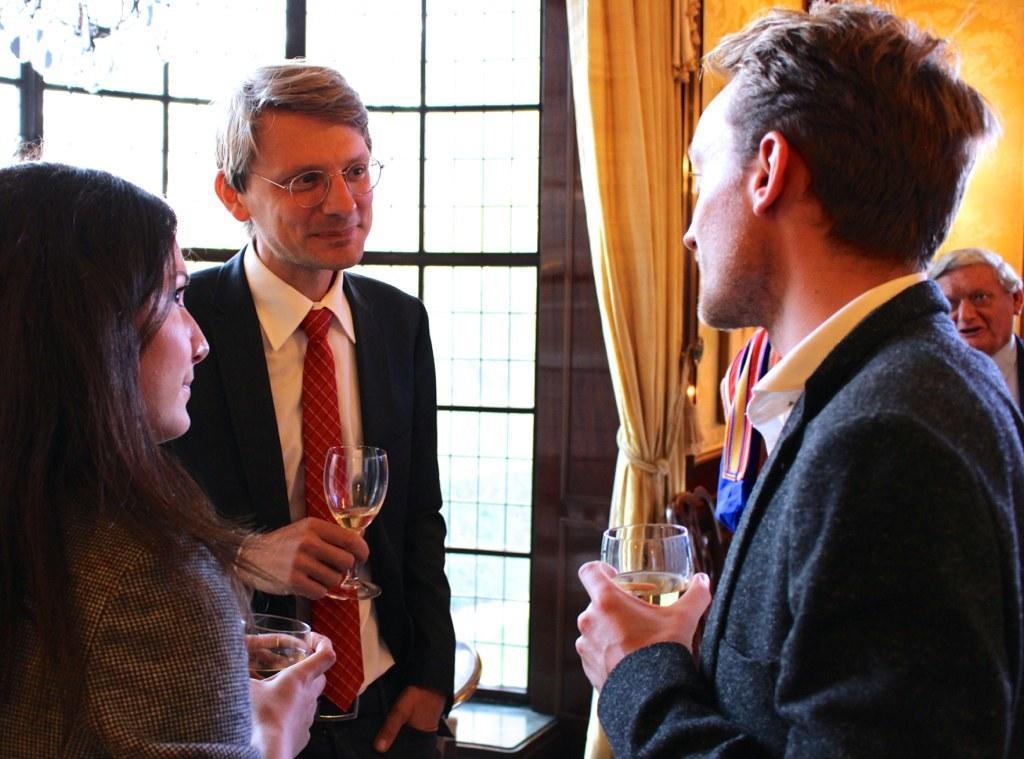Describe this image in one or two sentences. In this image there is a person wearing suit and tie. He is holding a glass having drink in it. He is wearing spectacles. Beside there is a woman holding a glass having drink in it. A person is holding glass. Behind him there is a person. There is a window having curtain. 